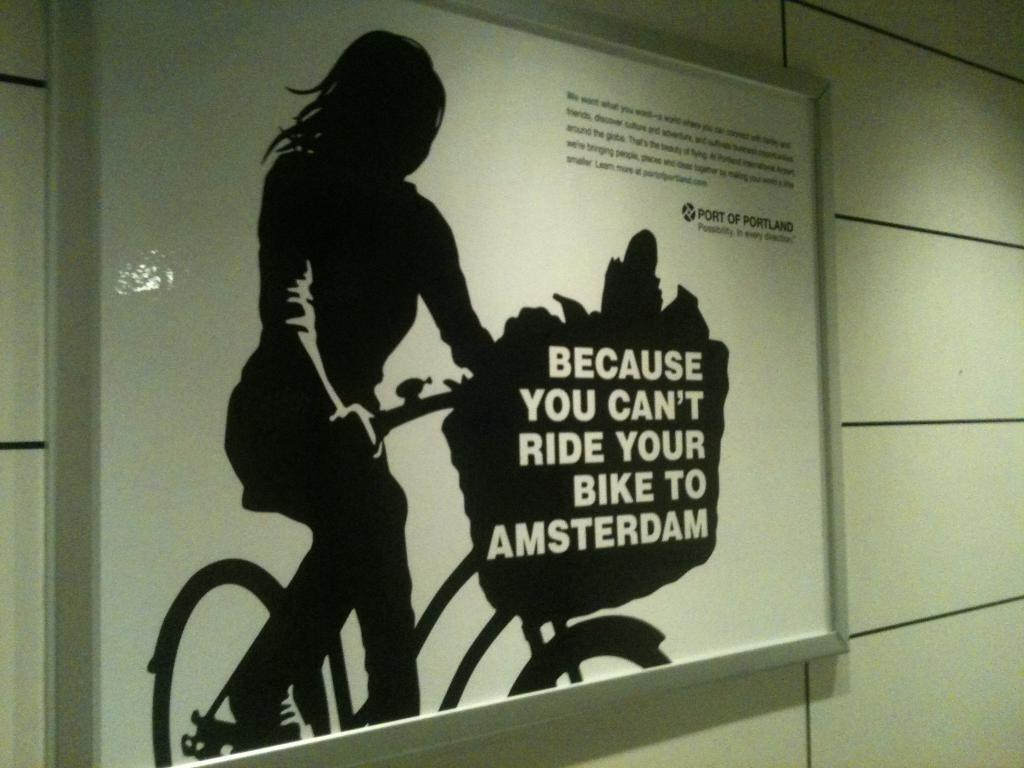What is the main object in the center of the image? There is a board in the center of the image. What can be seen on the board? There is text on the board. What is the girl doing in the image? The girl is sitting on a cycle. What can be seen in the background of the image? There is a wall in the background of the image. What type of holiday is the girl celebrating in the image? There is no indication of a holiday in the image; it simply shows a girl sitting on a cycle and a board with text. What boundary is depicted in the image? There is no boundary depicted in the image; it features a girl sitting on a cycle, a board with text, and a wall in the background. 